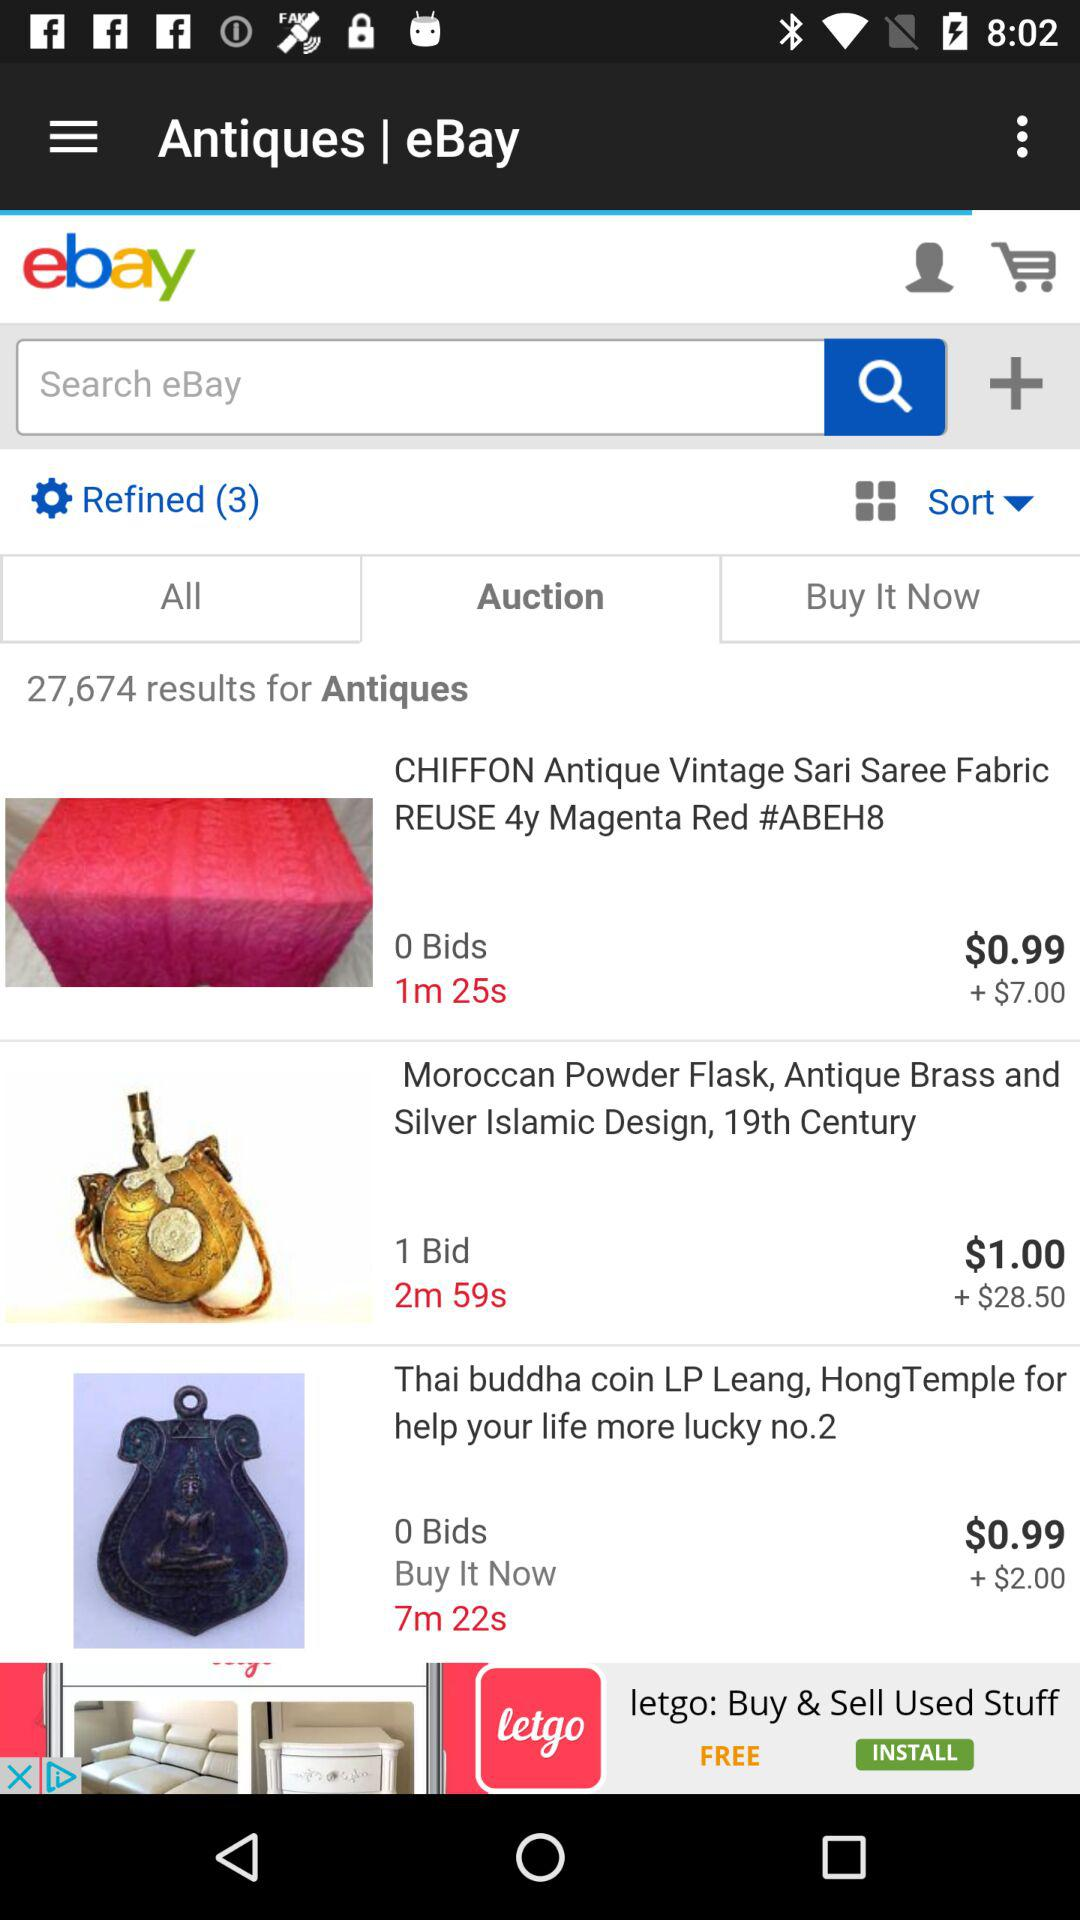What is the price of Chiffon antiques vintage sari saree fabric?
When the provided information is insufficient, respond with <no answer>. <no answer> 